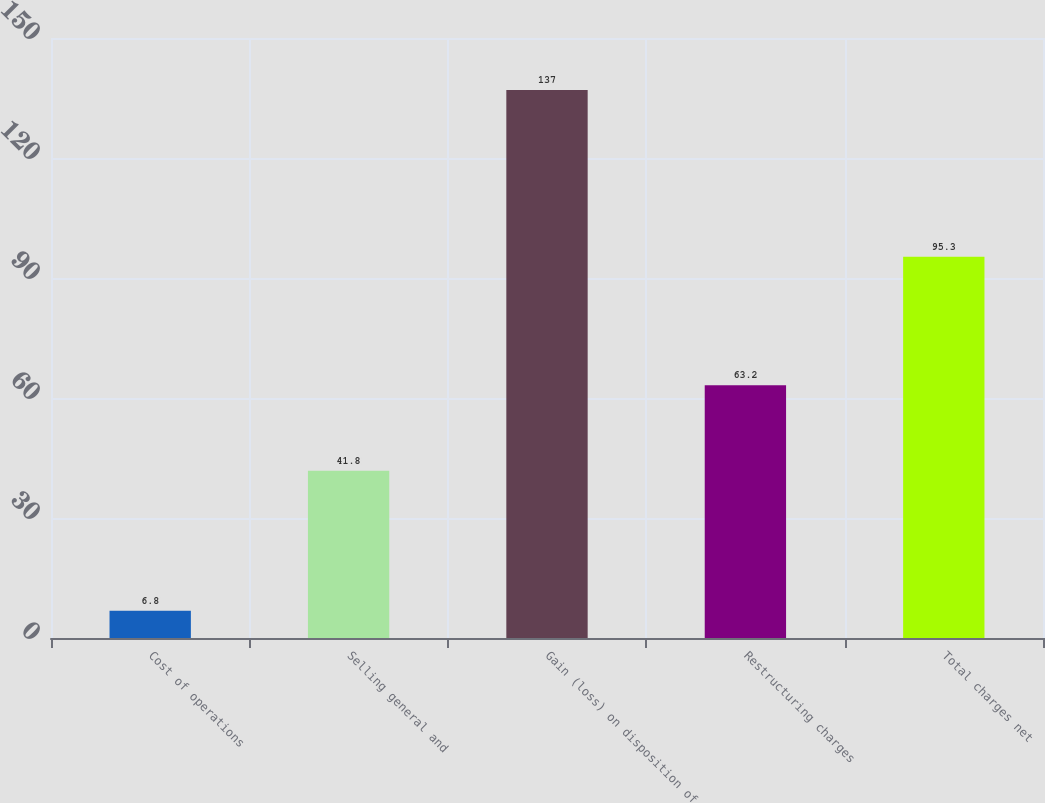Convert chart. <chart><loc_0><loc_0><loc_500><loc_500><bar_chart><fcel>Cost of operations<fcel>Selling general and<fcel>Gain (loss) on disposition of<fcel>Restructuring charges<fcel>Total charges net<nl><fcel>6.8<fcel>41.8<fcel>137<fcel>63.2<fcel>95.3<nl></chart> 